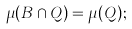Convert formula to latex. <formula><loc_0><loc_0><loc_500><loc_500>\mu ( B \cap Q ) = \mu ( Q ) ;</formula> 